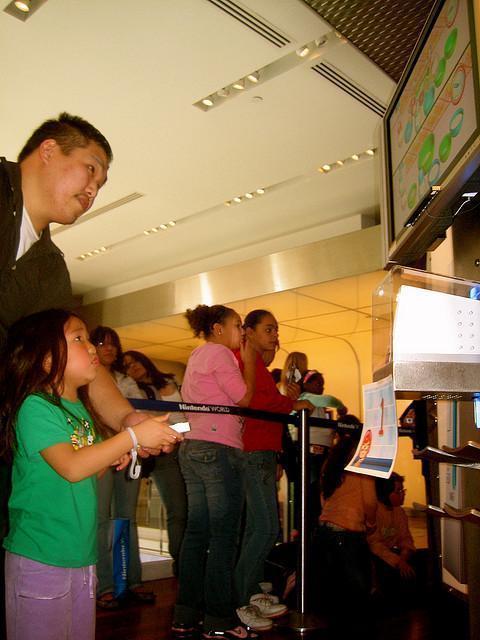What does the child hold in her hands?
Indicate the correct response by choosing from the four available options to answer the question.
Options: Phone, jewel box, tv remote, wii remote. Wii remote. 